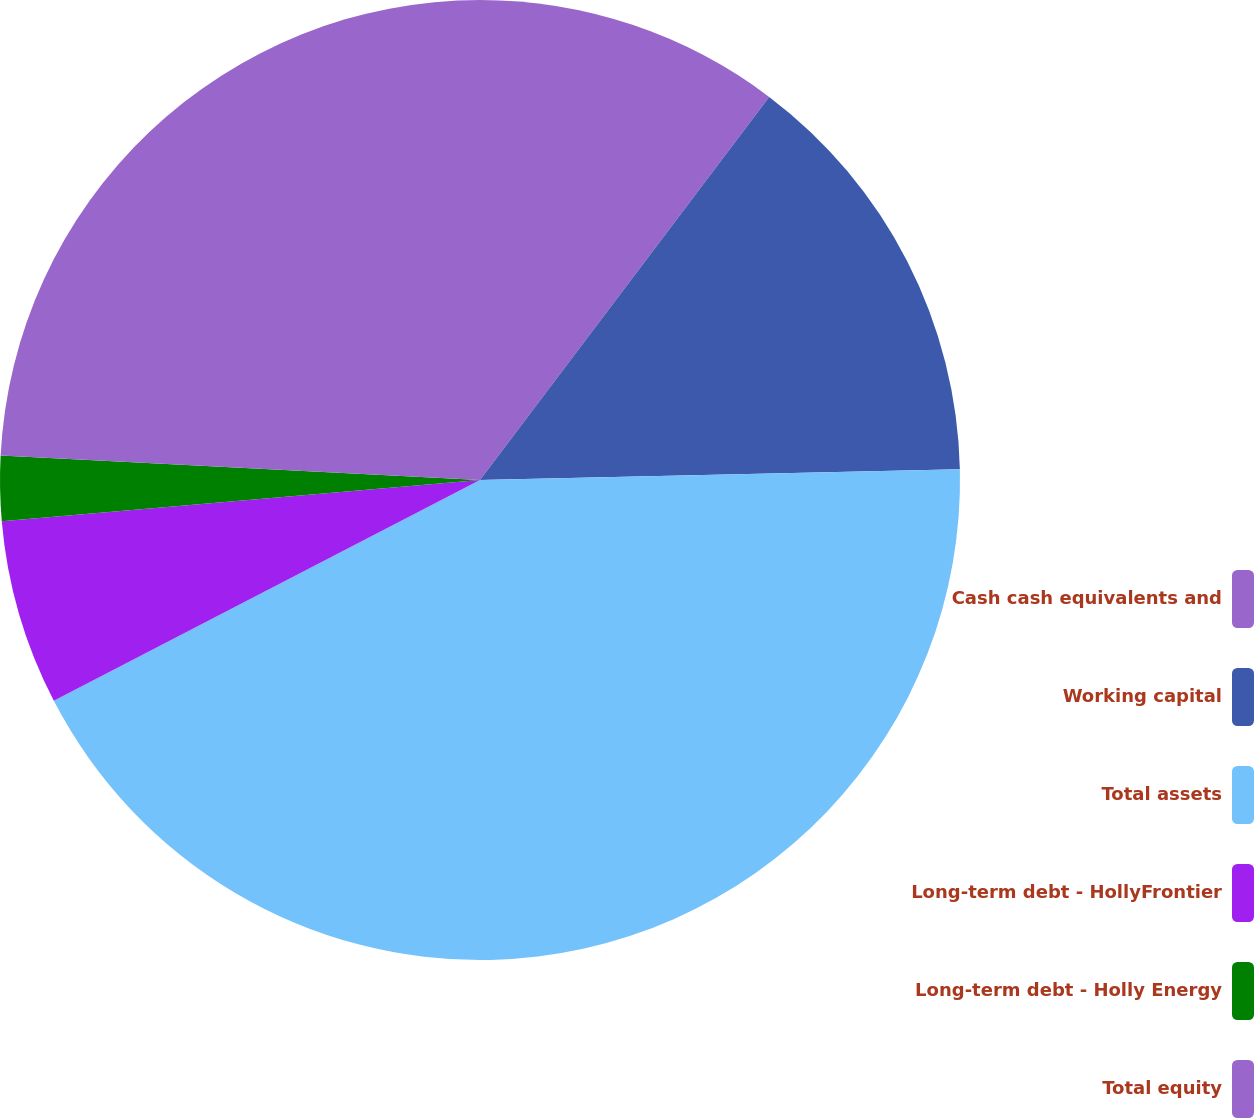<chart> <loc_0><loc_0><loc_500><loc_500><pie_chart><fcel>Cash cash equivalents and<fcel>Working capital<fcel>Total assets<fcel>Long-term debt - HollyFrontier<fcel>Long-term debt - Holly Energy<fcel>Total equity<nl><fcel>10.29%<fcel>14.35%<fcel>42.75%<fcel>6.24%<fcel>2.18%<fcel>24.19%<nl></chart> 